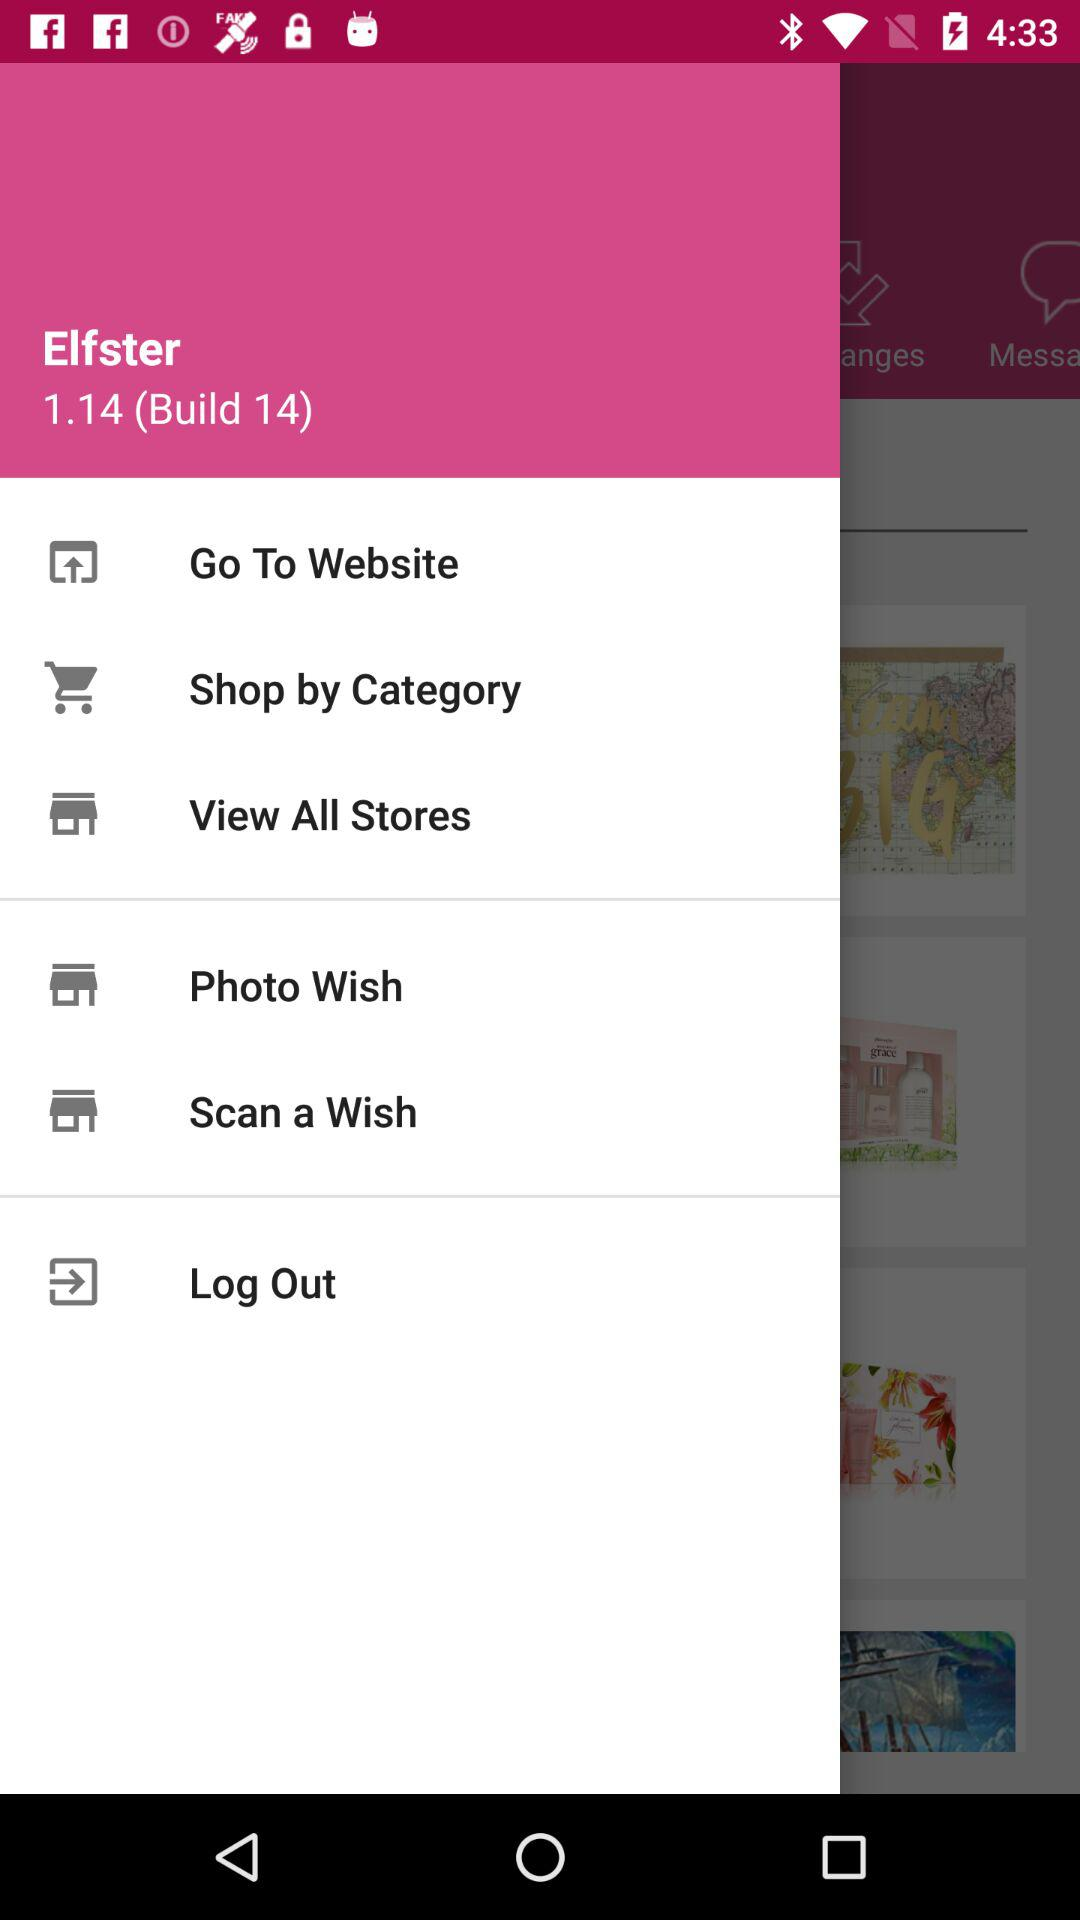What is the name of the application? The name of the application is "Elfster". 